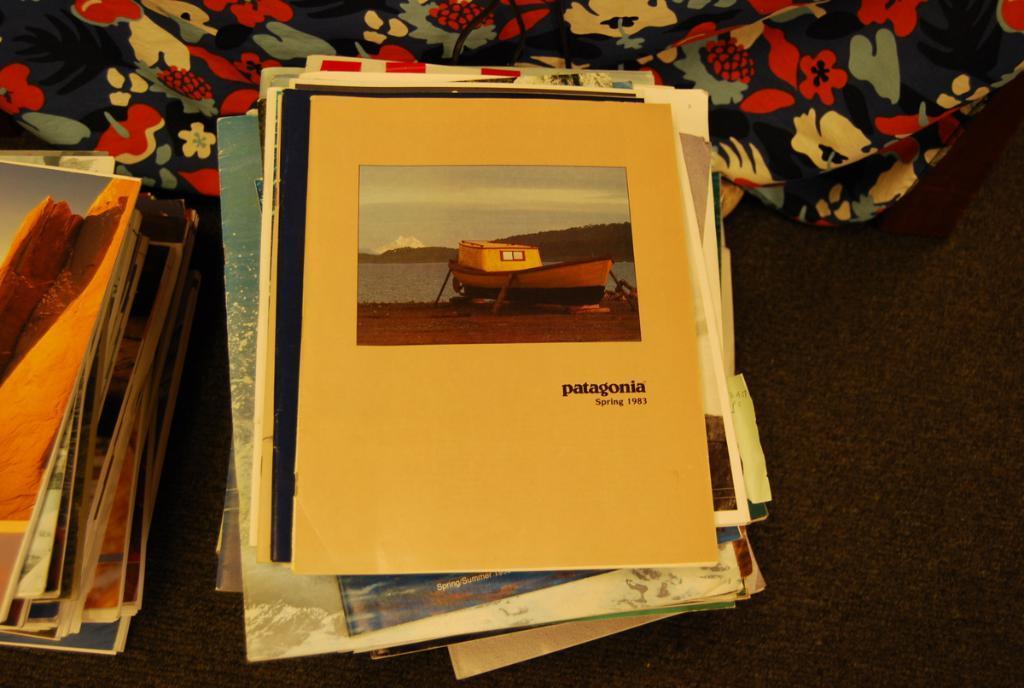Describe this image in one or two sentences. In this image we can see books and cloth on a platform. On the book we can see picture of a boat, water, mountain, and sky. There is something written on it. 